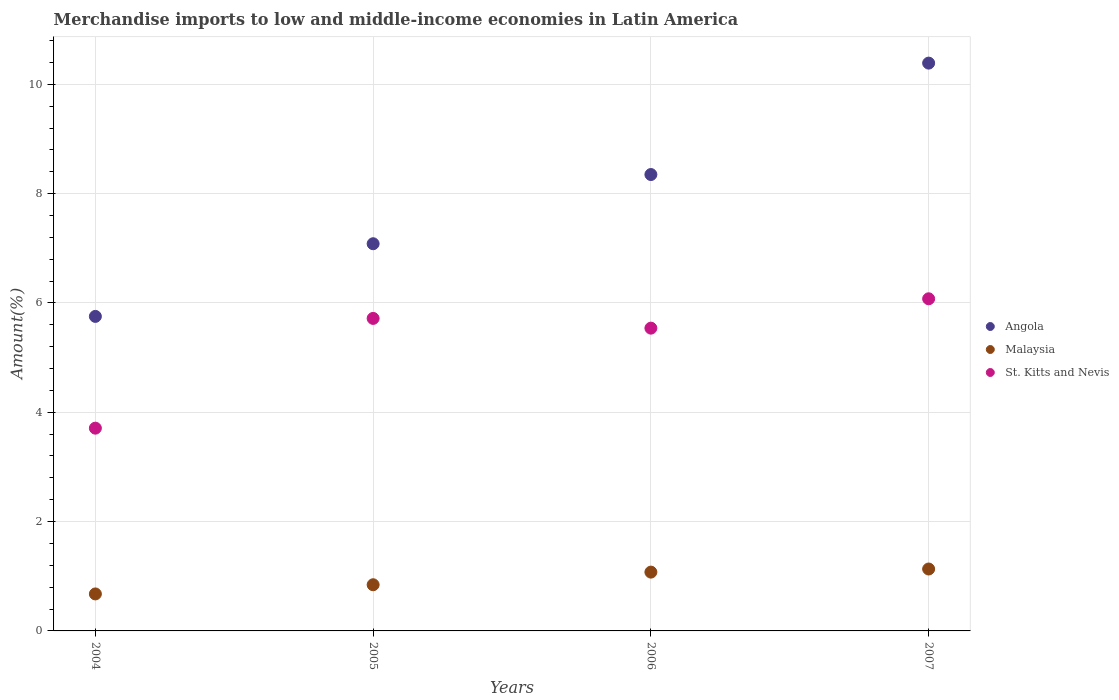Is the number of dotlines equal to the number of legend labels?
Keep it short and to the point. Yes. What is the percentage of amount earned from merchandise imports in Angola in 2005?
Offer a very short reply. 7.08. Across all years, what is the maximum percentage of amount earned from merchandise imports in Angola?
Your answer should be very brief. 10.39. Across all years, what is the minimum percentage of amount earned from merchandise imports in Malaysia?
Your answer should be very brief. 0.68. In which year was the percentage of amount earned from merchandise imports in Angola minimum?
Provide a succinct answer. 2004. What is the total percentage of amount earned from merchandise imports in St. Kitts and Nevis in the graph?
Your response must be concise. 21.04. What is the difference between the percentage of amount earned from merchandise imports in Angola in 2005 and that in 2007?
Provide a short and direct response. -3.3. What is the difference between the percentage of amount earned from merchandise imports in St. Kitts and Nevis in 2004 and the percentage of amount earned from merchandise imports in Malaysia in 2005?
Ensure brevity in your answer.  2.86. What is the average percentage of amount earned from merchandise imports in Angola per year?
Give a very brief answer. 7.89. In the year 2004, what is the difference between the percentage of amount earned from merchandise imports in Angola and percentage of amount earned from merchandise imports in St. Kitts and Nevis?
Make the answer very short. 2.04. In how many years, is the percentage of amount earned from merchandise imports in Malaysia greater than 6 %?
Keep it short and to the point. 0. What is the ratio of the percentage of amount earned from merchandise imports in St. Kitts and Nevis in 2005 to that in 2007?
Keep it short and to the point. 0.94. Is the difference between the percentage of amount earned from merchandise imports in Angola in 2005 and 2007 greater than the difference between the percentage of amount earned from merchandise imports in St. Kitts and Nevis in 2005 and 2007?
Your answer should be compact. No. What is the difference between the highest and the second highest percentage of amount earned from merchandise imports in Angola?
Ensure brevity in your answer.  2.04. What is the difference between the highest and the lowest percentage of amount earned from merchandise imports in St. Kitts and Nevis?
Provide a succinct answer. 2.37. Is it the case that in every year, the sum of the percentage of amount earned from merchandise imports in St. Kitts and Nevis and percentage of amount earned from merchandise imports in Angola  is greater than the percentage of amount earned from merchandise imports in Malaysia?
Your response must be concise. Yes. Is the percentage of amount earned from merchandise imports in St. Kitts and Nevis strictly greater than the percentage of amount earned from merchandise imports in Malaysia over the years?
Provide a succinct answer. Yes. How many years are there in the graph?
Keep it short and to the point. 4. What is the difference between two consecutive major ticks on the Y-axis?
Your answer should be compact. 2. Are the values on the major ticks of Y-axis written in scientific E-notation?
Give a very brief answer. No. How many legend labels are there?
Provide a succinct answer. 3. How are the legend labels stacked?
Offer a very short reply. Vertical. What is the title of the graph?
Give a very brief answer. Merchandise imports to low and middle-income economies in Latin America. Does "Papua New Guinea" appear as one of the legend labels in the graph?
Provide a succinct answer. No. What is the label or title of the X-axis?
Give a very brief answer. Years. What is the label or title of the Y-axis?
Provide a short and direct response. Amount(%). What is the Amount(%) in Angola in 2004?
Provide a succinct answer. 5.75. What is the Amount(%) of Malaysia in 2004?
Provide a succinct answer. 0.68. What is the Amount(%) in St. Kitts and Nevis in 2004?
Give a very brief answer. 3.71. What is the Amount(%) of Angola in 2005?
Your answer should be compact. 7.08. What is the Amount(%) of Malaysia in 2005?
Offer a terse response. 0.84. What is the Amount(%) in St. Kitts and Nevis in 2005?
Your response must be concise. 5.72. What is the Amount(%) in Angola in 2006?
Offer a terse response. 8.35. What is the Amount(%) in Malaysia in 2006?
Ensure brevity in your answer.  1.08. What is the Amount(%) of St. Kitts and Nevis in 2006?
Your response must be concise. 5.54. What is the Amount(%) of Angola in 2007?
Offer a very short reply. 10.39. What is the Amount(%) in Malaysia in 2007?
Provide a short and direct response. 1.13. What is the Amount(%) in St. Kitts and Nevis in 2007?
Ensure brevity in your answer.  6.08. Across all years, what is the maximum Amount(%) of Angola?
Make the answer very short. 10.39. Across all years, what is the maximum Amount(%) in Malaysia?
Your answer should be very brief. 1.13. Across all years, what is the maximum Amount(%) of St. Kitts and Nevis?
Offer a very short reply. 6.08. Across all years, what is the minimum Amount(%) of Angola?
Give a very brief answer. 5.75. Across all years, what is the minimum Amount(%) in Malaysia?
Provide a short and direct response. 0.68. Across all years, what is the minimum Amount(%) of St. Kitts and Nevis?
Offer a very short reply. 3.71. What is the total Amount(%) in Angola in the graph?
Ensure brevity in your answer.  31.57. What is the total Amount(%) of Malaysia in the graph?
Your answer should be compact. 3.73. What is the total Amount(%) in St. Kitts and Nevis in the graph?
Your response must be concise. 21.04. What is the difference between the Amount(%) in Angola in 2004 and that in 2005?
Offer a very short reply. -1.33. What is the difference between the Amount(%) in Malaysia in 2004 and that in 2005?
Your answer should be very brief. -0.17. What is the difference between the Amount(%) of St. Kitts and Nevis in 2004 and that in 2005?
Provide a succinct answer. -2.01. What is the difference between the Amount(%) of Angola in 2004 and that in 2006?
Give a very brief answer. -2.6. What is the difference between the Amount(%) in Malaysia in 2004 and that in 2006?
Ensure brevity in your answer.  -0.4. What is the difference between the Amount(%) of St. Kitts and Nevis in 2004 and that in 2006?
Give a very brief answer. -1.83. What is the difference between the Amount(%) in Angola in 2004 and that in 2007?
Keep it short and to the point. -4.63. What is the difference between the Amount(%) of Malaysia in 2004 and that in 2007?
Make the answer very short. -0.46. What is the difference between the Amount(%) in St. Kitts and Nevis in 2004 and that in 2007?
Ensure brevity in your answer.  -2.37. What is the difference between the Amount(%) in Angola in 2005 and that in 2006?
Provide a short and direct response. -1.27. What is the difference between the Amount(%) in Malaysia in 2005 and that in 2006?
Provide a succinct answer. -0.23. What is the difference between the Amount(%) of St. Kitts and Nevis in 2005 and that in 2006?
Your answer should be compact. 0.18. What is the difference between the Amount(%) in Angola in 2005 and that in 2007?
Offer a terse response. -3.3. What is the difference between the Amount(%) of Malaysia in 2005 and that in 2007?
Offer a very short reply. -0.29. What is the difference between the Amount(%) in St. Kitts and Nevis in 2005 and that in 2007?
Offer a very short reply. -0.36. What is the difference between the Amount(%) of Angola in 2006 and that in 2007?
Keep it short and to the point. -2.04. What is the difference between the Amount(%) of Malaysia in 2006 and that in 2007?
Your answer should be very brief. -0.06. What is the difference between the Amount(%) of St. Kitts and Nevis in 2006 and that in 2007?
Your response must be concise. -0.54. What is the difference between the Amount(%) in Angola in 2004 and the Amount(%) in Malaysia in 2005?
Offer a very short reply. 4.91. What is the difference between the Amount(%) of Angola in 2004 and the Amount(%) of St. Kitts and Nevis in 2005?
Your response must be concise. 0.04. What is the difference between the Amount(%) of Malaysia in 2004 and the Amount(%) of St. Kitts and Nevis in 2005?
Your answer should be compact. -5.04. What is the difference between the Amount(%) of Angola in 2004 and the Amount(%) of Malaysia in 2006?
Ensure brevity in your answer.  4.68. What is the difference between the Amount(%) of Angola in 2004 and the Amount(%) of St. Kitts and Nevis in 2006?
Your answer should be compact. 0.21. What is the difference between the Amount(%) in Malaysia in 2004 and the Amount(%) in St. Kitts and Nevis in 2006?
Ensure brevity in your answer.  -4.86. What is the difference between the Amount(%) of Angola in 2004 and the Amount(%) of Malaysia in 2007?
Provide a succinct answer. 4.62. What is the difference between the Amount(%) in Angola in 2004 and the Amount(%) in St. Kitts and Nevis in 2007?
Ensure brevity in your answer.  -0.32. What is the difference between the Amount(%) in Malaysia in 2004 and the Amount(%) in St. Kitts and Nevis in 2007?
Your answer should be very brief. -5.4. What is the difference between the Amount(%) of Angola in 2005 and the Amount(%) of Malaysia in 2006?
Offer a very short reply. 6.01. What is the difference between the Amount(%) in Angola in 2005 and the Amount(%) in St. Kitts and Nevis in 2006?
Your answer should be very brief. 1.54. What is the difference between the Amount(%) in Malaysia in 2005 and the Amount(%) in St. Kitts and Nevis in 2006?
Your answer should be compact. -4.69. What is the difference between the Amount(%) in Angola in 2005 and the Amount(%) in Malaysia in 2007?
Make the answer very short. 5.95. What is the difference between the Amount(%) of Angola in 2005 and the Amount(%) of St. Kitts and Nevis in 2007?
Your answer should be compact. 1.01. What is the difference between the Amount(%) of Malaysia in 2005 and the Amount(%) of St. Kitts and Nevis in 2007?
Your response must be concise. -5.23. What is the difference between the Amount(%) in Angola in 2006 and the Amount(%) in Malaysia in 2007?
Ensure brevity in your answer.  7.22. What is the difference between the Amount(%) of Angola in 2006 and the Amount(%) of St. Kitts and Nevis in 2007?
Your answer should be compact. 2.27. What is the average Amount(%) of Angola per year?
Make the answer very short. 7.89. What is the average Amount(%) of Malaysia per year?
Provide a short and direct response. 0.93. What is the average Amount(%) of St. Kitts and Nevis per year?
Your response must be concise. 5.26. In the year 2004, what is the difference between the Amount(%) of Angola and Amount(%) of Malaysia?
Offer a terse response. 5.08. In the year 2004, what is the difference between the Amount(%) in Angola and Amount(%) in St. Kitts and Nevis?
Give a very brief answer. 2.04. In the year 2004, what is the difference between the Amount(%) of Malaysia and Amount(%) of St. Kitts and Nevis?
Your answer should be compact. -3.03. In the year 2005, what is the difference between the Amount(%) of Angola and Amount(%) of Malaysia?
Give a very brief answer. 6.24. In the year 2005, what is the difference between the Amount(%) of Angola and Amount(%) of St. Kitts and Nevis?
Ensure brevity in your answer.  1.37. In the year 2005, what is the difference between the Amount(%) of Malaysia and Amount(%) of St. Kitts and Nevis?
Your response must be concise. -4.87. In the year 2006, what is the difference between the Amount(%) of Angola and Amount(%) of Malaysia?
Your answer should be compact. 7.27. In the year 2006, what is the difference between the Amount(%) of Angola and Amount(%) of St. Kitts and Nevis?
Keep it short and to the point. 2.81. In the year 2006, what is the difference between the Amount(%) in Malaysia and Amount(%) in St. Kitts and Nevis?
Provide a short and direct response. -4.46. In the year 2007, what is the difference between the Amount(%) of Angola and Amount(%) of Malaysia?
Provide a short and direct response. 9.25. In the year 2007, what is the difference between the Amount(%) of Angola and Amount(%) of St. Kitts and Nevis?
Offer a very short reply. 4.31. In the year 2007, what is the difference between the Amount(%) in Malaysia and Amount(%) in St. Kitts and Nevis?
Offer a terse response. -4.94. What is the ratio of the Amount(%) of Angola in 2004 to that in 2005?
Make the answer very short. 0.81. What is the ratio of the Amount(%) in Malaysia in 2004 to that in 2005?
Keep it short and to the point. 0.8. What is the ratio of the Amount(%) of St. Kitts and Nevis in 2004 to that in 2005?
Offer a very short reply. 0.65. What is the ratio of the Amount(%) in Angola in 2004 to that in 2006?
Keep it short and to the point. 0.69. What is the ratio of the Amount(%) of Malaysia in 2004 to that in 2006?
Ensure brevity in your answer.  0.63. What is the ratio of the Amount(%) in St. Kitts and Nevis in 2004 to that in 2006?
Your response must be concise. 0.67. What is the ratio of the Amount(%) of Angola in 2004 to that in 2007?
Offer a very short reply. 0.55. What is the ratio of the Amount(%) of Malaysia in 2004 to that in 2007?
Your answer should be very brief. 0.6. What is the ratio of the Amount(%) of St. Kitts and Nevis in 2004 to that in 2007?
Offer a terse response. 0.61. What is the ratio of the Amount(%) in Angola in 2005 to that in 2006?
Offer a very short reply. 0.85. What is the ratio of the Amount(%) of Malaysia in 2005 to that in 2006?
Give a very brief answer. 0.79. What is the ratio of the Amount(%) of St. Kitts and Nevis in 2005 to that in 2006?
Your response must be concise. 1.03. What is the ratio of the Amount(%) in Angola in 2005 to that in 2007?
Give a very brief answer. 0.68. What is the ratio of the Amount(%) of Malaysia in 2005 to that in 2007?
Keep it short and to the point. 0.75. What is the ratio of the Amount(%) in St. Kitts and Nevis in 2005 to that in 2007?
Provide a succinct answer. 0.94. What is the ratio of the Amount(%) in Angola in 2006 to that in 2007?
Your response must be concise. 0.8. What is the ratio of the Amount(%) of Malaysia in 2006 to that in 2007?
Provide a short and direct response. 0.95. What is the ratio of the Amount(%) in St. Kitts and Nevis in 2006 to that in 2007?
Your answer should be very brief. 0.91. What is the difference between the highest and the second highest Amount(%) of Angola?
Give a very brief answer. 2.04. What is the difference between the highest and the second highest Amount(%) in Malaysia?
Your answer should be compact. 0.06. What is the difference between the highest and the second highest Amount(%) of St. Kitts and Nevis?
Ensure brevity in your answer.  0.36. What is the difference between the highest and the lowest Amount(%) of Angola?
Ensure brevity in your answer.  4.63. What is the difference between the highest and the lowest Amount(%) in Malaysia?
Offer a terse response. 0.46. What is the difference between the highest and the lowest Amount(%) of St. Kitts and Nevis?
Offer a terse response. 2.37. 